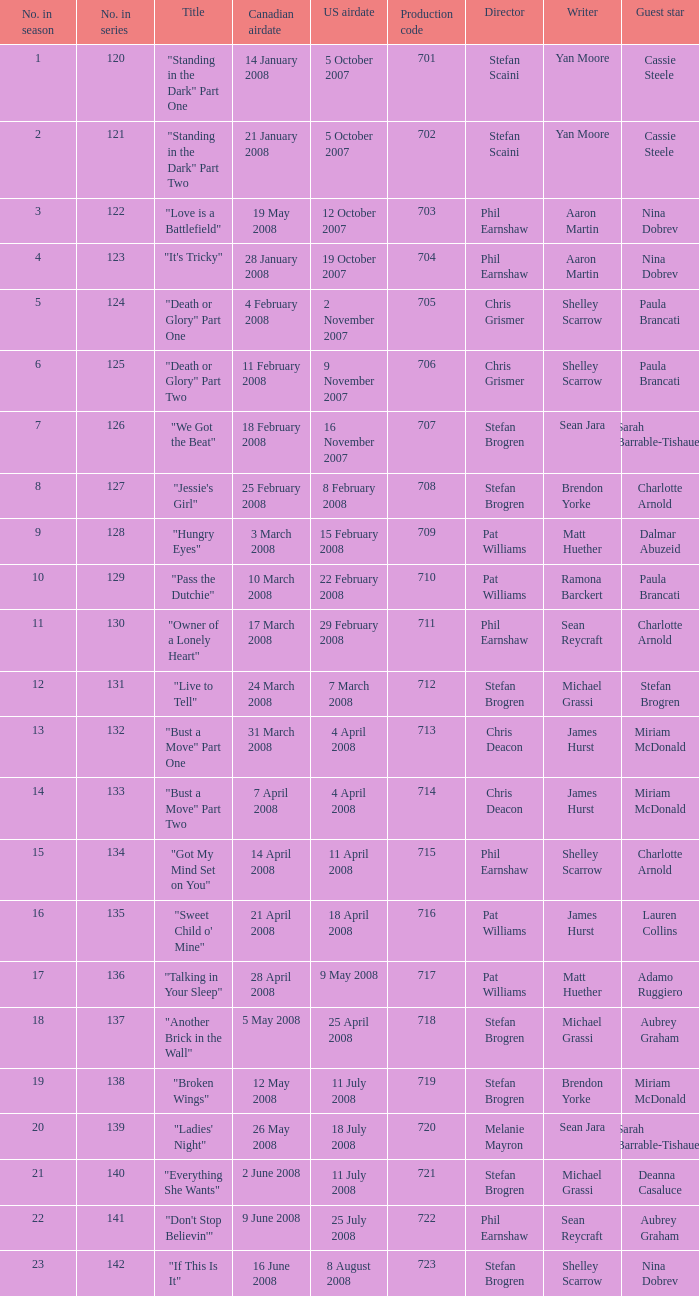For the episode(s) aired in the U.S. on 4 april 2008, what were the names? "Bust a Move" Part One, "Bust a Move" Part Two. 